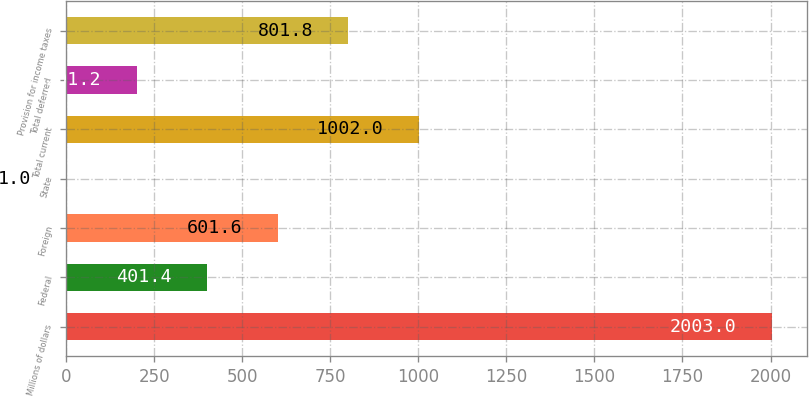<chart> <loc_0><loc_0><loc_500><loc_500><bar_chart><fcel>Millions of dollars<fcel>Federal<fcel>Foreign<fcel>State<fcel>Total current<fcel>Total deferred<fcel>Provision for income taxes<nl><fcel>2003<fcel>401.4<fcel>601.6<fcel>1<fcel>1002<fcel>201.2<fcel>801.8<nl></chart> 